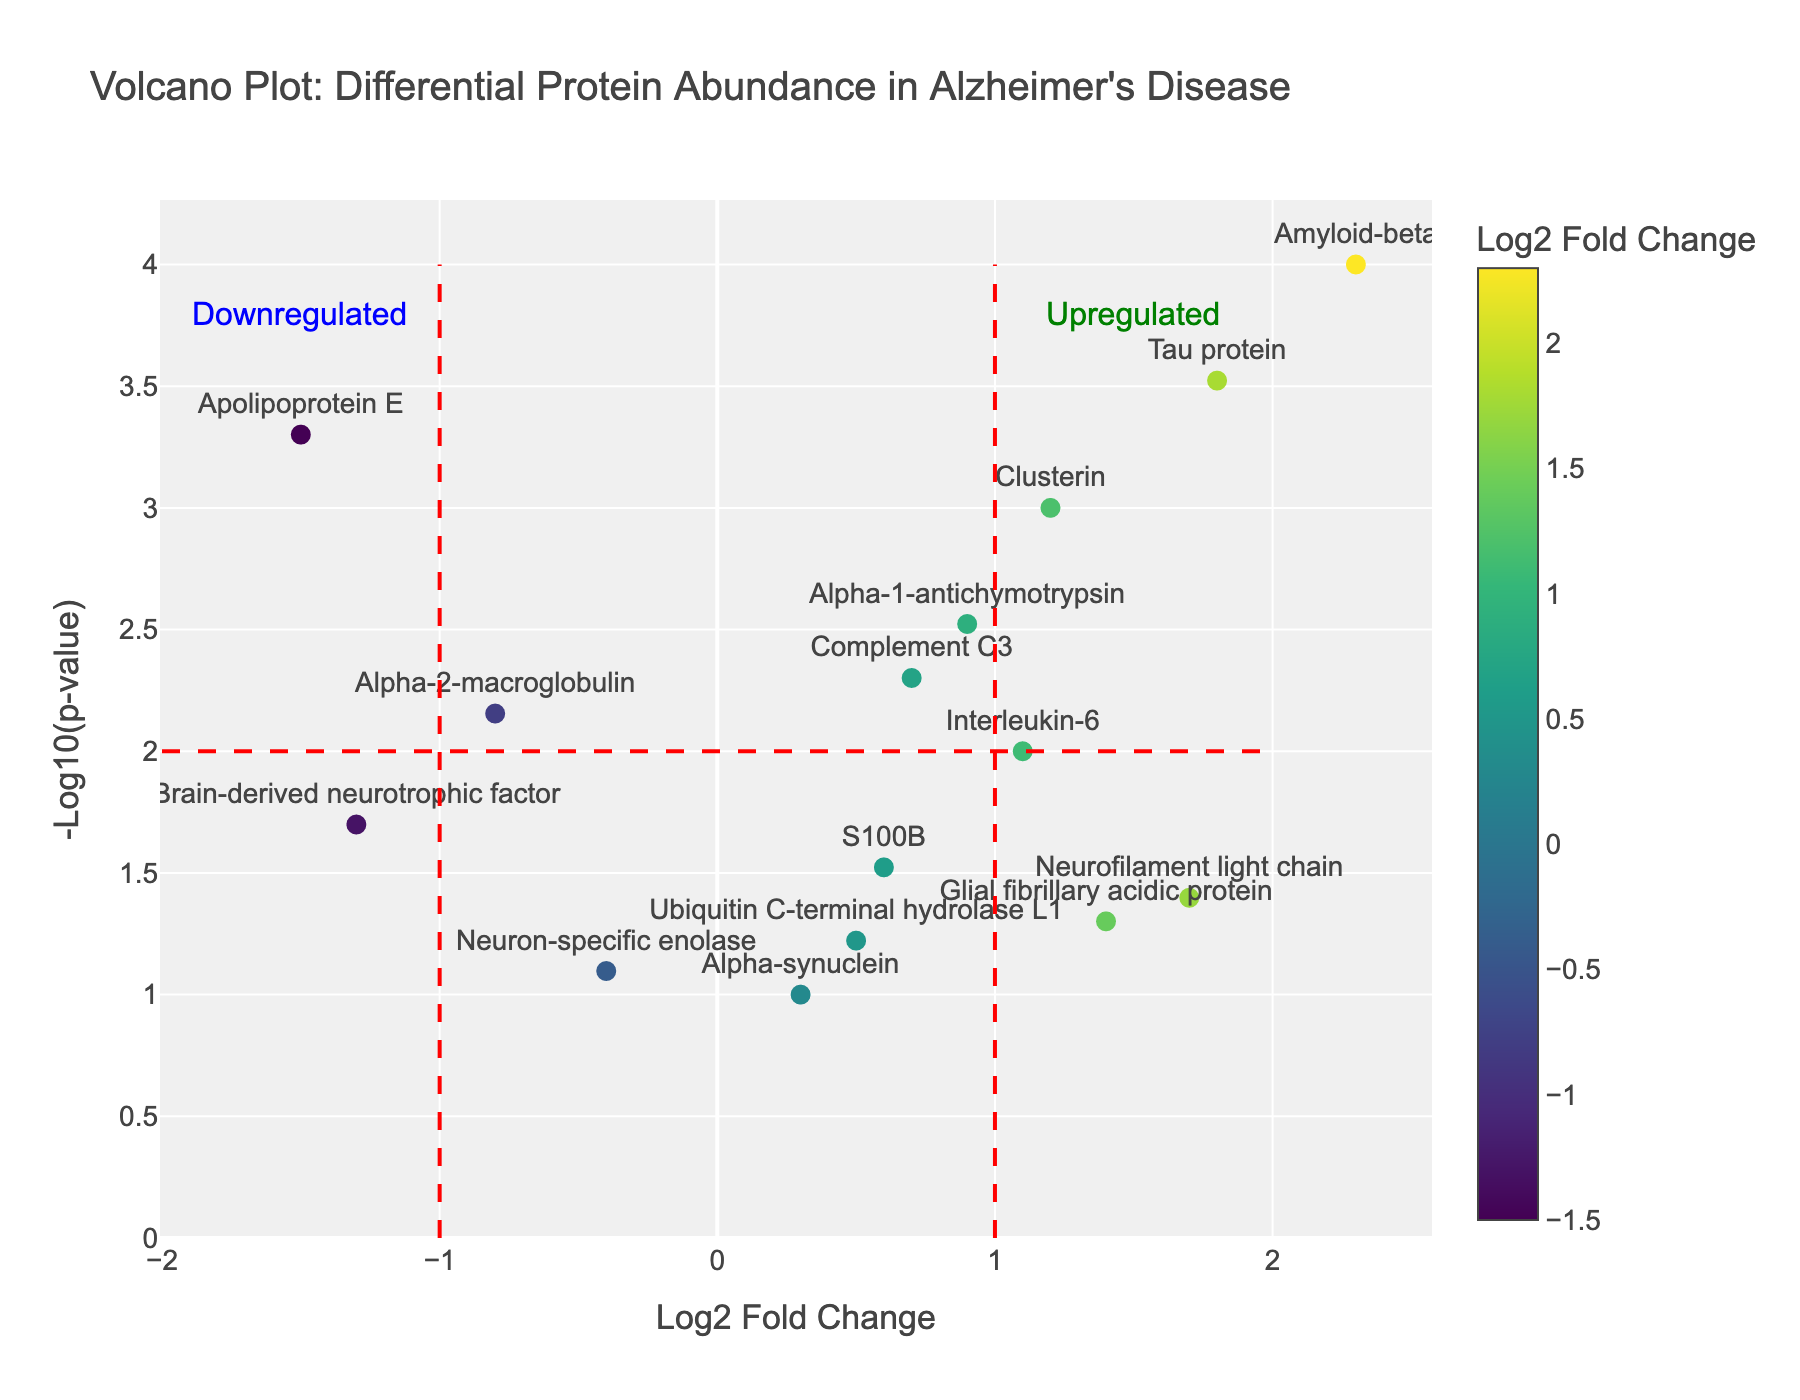What is the title of the plot? The title of the plot is located at the top and clearly states what the figure represents.
Answer: Volcano Plot: Differential Protein Abundance in Alzheimer's Disease How is the Log2 Fold Change represented in the plot? The Log2 Fold Change is represented along the x-axis, and also by the color scale of the data points, ranging from light to dark colors.
Answer: By the x-axis and color scale Which protein has the highest Log2 Fold Change? To find the protein with the highest Log2 Fold Change, look for the data point furthest to the right on the x-axis. The protein name is typically labeled nearby or can be found in the hover text.
Answer: Amyloid-beta What is the -log10(p-value) for the Tau protein, and how is it calculated? For the Tau protein, find its position on the plot or in the data table. The -log10(p-value) is calculated by taking the negative logarithm base 10 of the p-value. Tau protein has a p-value of 0.0003, so -log10(0.0003) ≈ 3.52.
Answer: ≈ 3.52 Which protein is the most statistically significant based on its p-value? The most statistically significant protein will have the highest -log10(p-value), indicated by the point highest on the y-axis. Amyloid-beta has the highest -log10(p-value).
Answer: Amyloid-beta How many proteins are considered upregulated, according to the threshold lines? Upregulated proteins are those with Log2 Fold Change > 1 and -log10(p-value) > 2. Count the points meeting these criteria on the plot.
Answer: 3 (Amyloid-beta, Tau protein, and Clusterin) Which protein has a nearly neutral Log2 Fold Change but still shows statistical significance? Proteins with a Log2 Fold Change close to zero and a higher -log10(p-value) in the plot are nearly neutral but significant. Alpha-1-antichymotrypsin is a suitable candidate.
Answer: Alpha-1-antichymotrypsin What does a point in the upper left quadrant of the plot represent? Points in the upper left quadrant have a negative Log2 Fold Change and a high -log10(p-value), indicating downregulated proteins with high statistical significance.
Answer: Downregulated and statistically significant Can you list all proteins that fall below the threshold lines for statistical significance? Proteins below the -log10(p-value) threshold line of 2 are considered not statistically significant. Check points with -log10(p-value) < 2.
Answer: Ubiquitin C-terminal hydrolase L1, Neuron-specific enolase, Alpha-synuclein Which proteins show a negative Log2 Fold Change but are still statistically significant? Look at points to the left of the x-axis (negative Log2 Fold Change) and above the y-axis threshold line (-log10(p-value) > 2). Apolipoprotein E and Brain-derived neurotrophic factor fit this description.
Answer: Apolipoprotein E, Brain-derived neurotrophic factor 